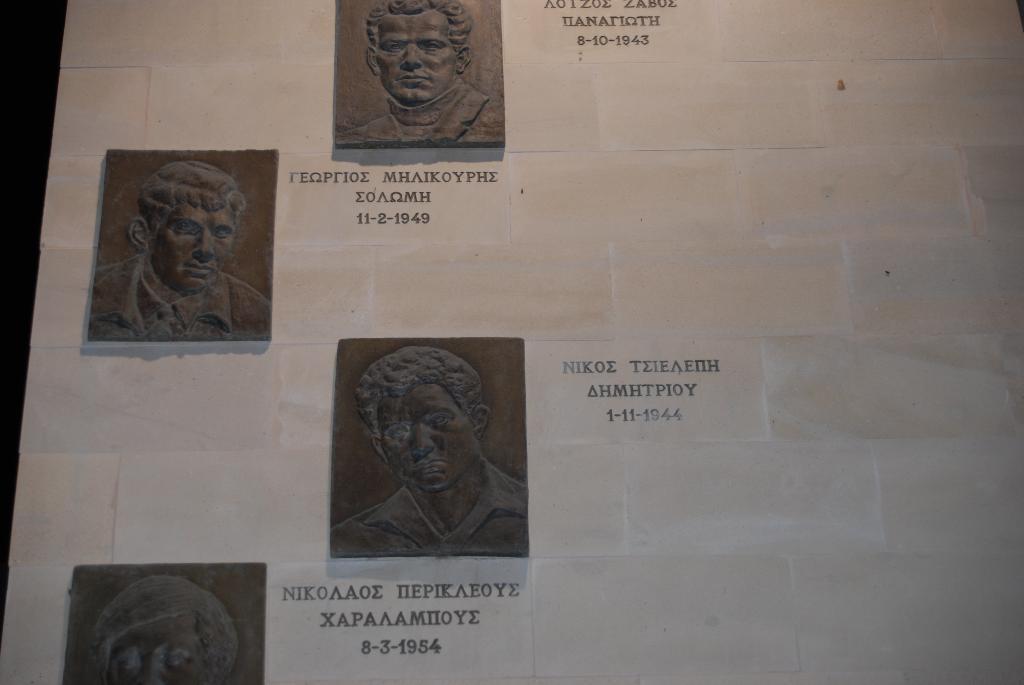Could you give a brief overview of what you see in this image? In this image there are carved sculptures with dates and names on the wall. 